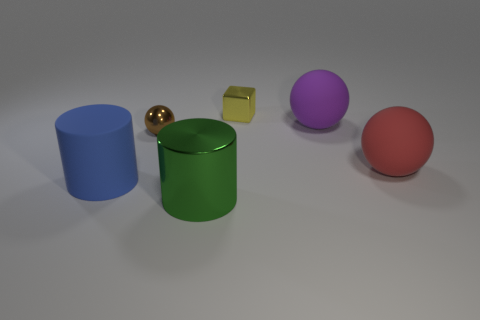Add 3 big gray metal objects. How many objects exist? 9 Subtract all cylinders. How many objects are left? 4 Subtract all yellow shiny objects. Subtract all yellow shiny cylinders. How many objects are left? 5 Add 5 red things. How many red things are left? 6 Add 3 small spheres. How many small spheres exist? 4 Subtract 0 purple cylinders. How many objects are left? 6 